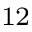Convert formula to latex. <formula><loc_0><loc_0><loc_500><loc_500>^ { 1 2 }</formula> 